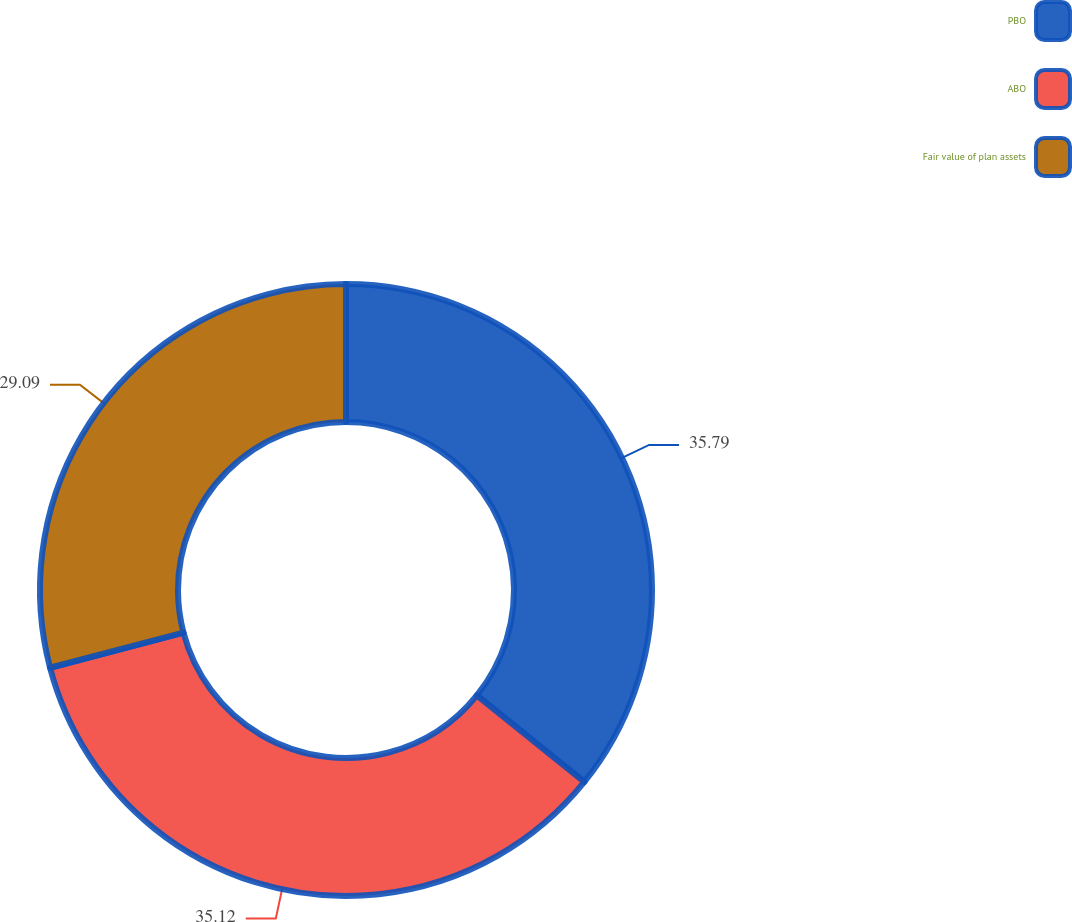Convert chart. <chart><loc_0><loc_0><loc_500><loc_500><pie_chart><fcel>PBO<fcel>ABO<fcel>Fair value of plan assets<nl><fcel>35.79%<fcel>35.12%<fcel>29.09%<nl></chart> 